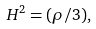<formula> <loc_0><loc_0><loc_500><loc_500>H ^ { 2 } = ( \rho / 3 ) ,</formula> 